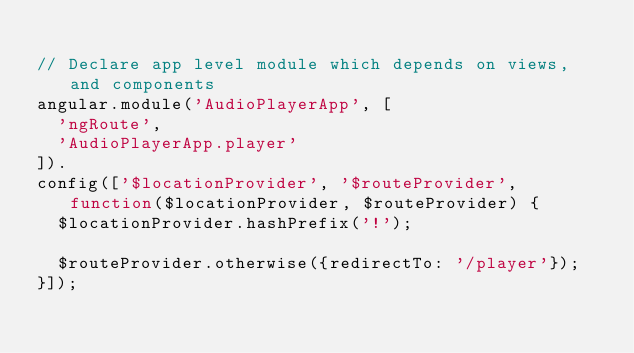Convert code to text. <code><loc_0><loc_0><loc_500><loc_500><_JavaScript_>
// Declare app level module which depends on views, and components
angular.module('AudioPlayerApp', [
  'ngRoute',
  'AudioPlayerApp.player'
]).
config(['$locationProvider', '$routeProvider', function($locationProvider, $routeProvider) {
  $locationProvider.hashPrefix('!');

  $routeProvider.otherwise({redirectTo: '/player'});
}]);
</code> 